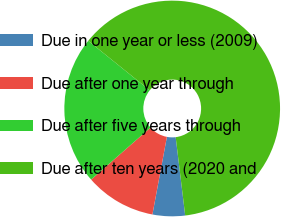Convert chart. <chart><loc_0><loc_0><loc_500><loc_500><pie_chart><fcel>Due in one year or less (2009)<fcel>Due after one year through<fcel>Due after five years through<fcel>Due after ten years (2020 and<nl><fcel>4.86%<fcel>10.6%<fcel>22.26%<fcel>62.28%<nl></chart> 